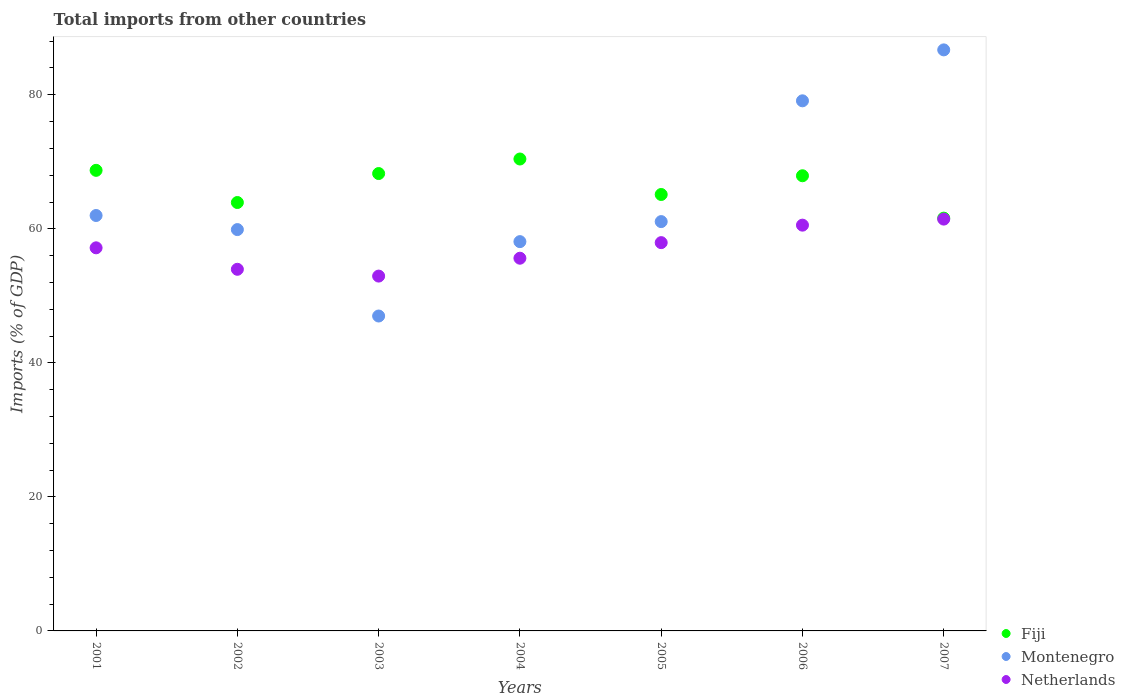Is the number of dotlines equal to the number of legend labels?
Make the answer very short. Yes. What is the total imports in Fiji in 2002?
Offer a very short reply. 63.92. Across all years, what is the maximum total imports in Fiji?
Your answer should be very brief. 70.42. Across all years, what is the minimum total imports in Fiji?
Offer a terse response. 61.59. What is the total total imports in Fiji in the graph?
Provide a short and direct response. 465.94. What is the difference between the total imports in Netherlands in 2002 and that in 2003?
Provide a succinct answer. 1.01. What is the difference between the total imports in Fiji in 2003 and the total imports in Montenegro in 2005?
Make the answer very short. 7.17. What is the average total imports in Netherlands per year?
Your answer should be very brief. 57.09. In the year 2004, what is the difference between the total imports in Netherlands and total imports in Fiji?
Make the answer very short. -14.8. What is the ratio of the total imports in Montenegro in 2001 to that in 2004?
Ensure brevity in your answer.  1.07. Is the total imports in Netherlands in 2001 less than that in 2004?
Ensure brevity in your answer.  No. What is the difference between the highest and the second highest total imports in Montenegro?
Your response must be concise. 7.6. What is the difference between the highest and the lowest total imports in Netherlands?
Your answer should be very brief. 8.5. Is it the case that in every year, the sum of the total imports in Montenegro and total imports in Fiji  is greater than the total imports in Netherlands?
Provide a short and direct response. Yes. Is the total imports in Netherlands strictly less than the total imports in Fiji over the years?
Provide a succinct answer. Yes. How many legend labels are there?
Provide a succinct answer. 3. What is the title of the graph?
Your answer should be very brief. Total imports from other countries. Does "Northern Mariana Islands" appear as one of the legend labels in the graph?
Keep it short and to the point. No. What is the label or title of the X-axis?
Your answer should be very brief. Years. What is the label or title of the Y-axis?
Provide a short and direct response. Imports (% of GDP). What is the Imports (% of GDP) in Fiji in 2001?
Your answer should be compact. 68.73. What is the Imports (% of GDP) of Montenegro in 2001?
Your answer should be compact. 61.99. What is the Imports (% of GDP) of Netherlands in 2001?
Keep it short and to the point. 57.16. What is the Imports (% of GDP) in Fiji in 2002?
Provide a short and direct response. 63.92. What is the Imports (% of GDP) in Montenegro in 2002?
Your answer should be very brief. 59.88. What is the Imports (% of GDP) of Netherlands in 2002?
Your answer should be very brief. 53.96. What is the Imports (% of GDP) in Fiji in 2003?
Provide a succinct answer. 68.25. What is the Imports (% of GDP) of Montenegro in 2003?
Your answer should be compact. 46.99. What is the Imports (% of GDP) in Netherlands in 2003?
Offer a very short reply. 52.95. What is the Imports (% of GDP) in Fiji in 2004?
Your answer should be compact. 70.42. What is the Imports (% of GDP) in Montenegro in 2004?
Give a very brief answer. 58.09. What is the Imports (% of GDP) of Netherlands in 2004?
Keep it short and to the point. 55.61. What is the Imports (% of GDP) in Fiji in 2005?
Provide a short and direct response. 65.12. What is the Imports (% of GDP) of Montenegro in 2005?
Keep it short and to the point. 61.08. What is the Imports (% of GDP) in Netherlands in 2005?
Give a very brief answer. 57.94. What is the Imports (% of GDP) in Fiji in 2006?
Your answer should be very brief. 67.92. What is the Imports (% of GDP) of Montenegro in 2006?
Give a very brief answer. 79.1. What is the Imports (% of GDP) in Netherlands in 2006?
Provide a succinct answer. 60.55. What is the Imports (% of GDP) in Fiji in 2007?
Your answer should be very brief. 61.59. What is the Imports (% of GDP) of Montenegro in 2007?
Make the answer very short. 86.7. What is the Imports (% of GDP) in Netherlands in 2007?
Provide a short and direct response. 61.45. Across all years, what is the maximum Imports (% of GDP) of Fiji?
Provide a short and direct response. 70.42. Across all years, what is the maximum Imports (% of GDP) in Montenegro?
Offer a terse response. 86.7. Across all years, what is the maximum Imports (% of GDP) of Netherlands?
Provide a short and direct response. 61.45. Across all years, what is the minimum Imports (% of GDP) in Fiji?
Ensure brevity in your answer.  61.59. Across all years, what is the minimum Imports (% of GDP) in Montenegro?
Offer a terse response. 46.99. Across all years, what is the minimum Imports (% of GDP) of Netherlands?
Make the answer very short. 52.95. What is the total Imports (% of GDP) in Fiji in the graph?
Ensure brevity in your answer.  465.94. What is the total Imports (% of GDP) in Montenegro in the graph?
Provide a succinct answer. 453.82. What is the total Imports (% of GDP) in Netherlands in the graph?
Your response must be concise. 399.61. What is the difference between the Imports (% of GDP) of Fiji in 2001 and that in 2002?
Provide a short and direct response. 4.8. What is the difference between the Imports (% of GDP) of Montenegro in 2001 and that in 2002?
Your response must be concise. 2.1. What is the difference between the Imports (% of GDP) in Netherlands in 2001 and that in 2002?
Offer a terse response. 3.2. What is the difference between the Imports (% of GDP) of Fiji in 2001 and that in 2003?
Your response must be concise. 0.48. What is the difference between the Imports (% of GDP) of Montenegro in 2001 and that in 2003?
Provide a succinct answer. 15. What is the difference between the Imports (% of GDP) of Netherlands in 2001 and that in 2003?
Provide a succinct answer. 4.22. What is the difference between the Imports (% of GDP) of Fiji in 2001 and that in 2004?
Give a very brief answer. -1.69. What is the difference between the Imports (% of GDP) of Montenegro in 2001 and that in 2004?
Give a very brief answer. 3.9. What is the difference between the Imports (% of GDP) of Netherlands in 2001 and that in 2004?
Provide a succinct answer. 1.55. What is the difference between the Imports (% of GDP) of Fiji in 2001 and that in 2005?
Your answer should be compact. 3.6. What is the difference between the Imports (% of GDP) of Montenegro in 2001 and that in 2005?
Your response must be concise. 0.91. What is the difference between the Imports (% of GDP) of Netherlands in 2001 and that in 2005?
Your response must be concise. -0.77. What is the difference between the Imports (% of GDP) in Fiji in 2001 and that in 2006?
Your answer should be very brief. 0.81. What is the difference between the Imports (% of GDP) of Montenegro in 2001 and that in 2006?
Your response must be concise. -17.11. What is the difference between the Imports (% of GDP) of Netherlands in 2001 and that in 2006?
Your answer should be compact. -3.38. What is the difference between the Imports (% of GDP) of Fiji in 2001 and that in 2007?
Offer a very short reply. 7.13. What is the difference between the Imports (% of GDP) in Montenegro in 2001 and that in 2007?
Keep it short and to the point. -24.71. What is the difference between the Imports (% of GDP) in Netherlands in 2001 and that in 2007?
Give a very brief answer. -4.29. What is the difference between the Imports (% of GDP) of Fiji in 2002 and that in 2003?
Provide a short and direct response. -4.32. What is the difference between the Imports (% of GDP) of Montenegro in 2002 and that in 2003?
Give a very brief answer. 12.9. What is the difference between the Imports (% of GDP) of Netherlands in 2002 and that in 2003?
Offer a very short reply. 1.01. What is the difference between the Imports (% of GDP) of Fiji in 2002 and that in 2004?
Offer a very short reply. -6.49. What is the difference between the Imports (% of GDP) in Montenegro in 2002 and that in 2004?
Your answer should be very brief. 1.8. What is the difference between the Imports (% of GDP) in Netherlands in 2002 and that in 2004?
Make the answer very short. -1.65. What is the difference between the Imports (% of GDP) in Fiji in 2002 and that in 2005?
Your answer should be very brief. -1.2. What is the difference between the Imports (% of GDP) in Montenegro in 2002 and that in 2005?
Offer a terse response. -1.19. What is the difference between the Imports (% of GDP) in Netherlands in 2002 and that in 2005?
Offer a very short reply. -3.98. What is the difference between the Imports (% of GDP) of Fiji in 2002 and that in 2006?
Offer a very short reply. -3.99. What is the difference between the Imports (% of GDP) of Montenegro in 2002 and that in 2006?
Your response must be concise. -19.21. What is the difference between the Imports (% of GDP) of Netherlands in 2002 and that in 2006?
Ensure brevity in your answer.  -6.59. What is the difference between the Imports (% of GDP) of Fiji in 2002 and that in 2007?
Ensure brevity in your answer.  2.33. What is the difference between the Imports (% of GDP) in Montenegro in 2002 and that in 2007?
Provide a short and direct response. -26.81. What is the difference between the Imports (% of GDP) in Netherlands in 2002 and that in 2007?
Give a very brief answer. -7.49. What is the difference between the Imports (% of GDP) in Fiji in 2003 and that in 2004?
Your answer should be very brief. -2.17. What is the difference between the Imports (% of GDP) of Montenegro in 2003 and that in 2004?
Your response must be concise. -11.1. What is the difference between the Imports (% of GDP) of Netherlands in 2003 and that in 2004?
Give a very brief answer. -2.67. What is the difference between the Imports (% of GDP) in Fiji in 2003 and that in 2005?
Your answer should be compact. 3.13. What is the difference between the Imports (% of GDP) of Montenegro in 2003 and that in 2005?
Give a very brief answer. -14.09. What is the difference between the Imports (% of GDP) in Netherlands in 2003 and that in 2005?
Make the answer very short. -4.99. What is the difference between the Imports (% of GDP) in Fiji in 2003 and that in 2006?
Provide a succinct answer. 0.33. What is the difference between the Imports (% of GDP) of Montenegro in 2003 and that in 2006?
Your answer should be very brief. -32.11. What is the difference between the Imports (% of GDP) in Netherlands in 2003 and that in 2006?
Make the answer very short. -7.6. What is the difference between the Imports (% of GDP) of Fiji in 2003 and that in 2007?
Give a very brief answer. 6.65. What is the difference between the Imports (% of GDP) of Montenegro in 2003 and that in 2007?
Offer a terse response. -39.71. What is the difference between the Imports (% of GDP) of Netherlands in 2003 and that in 2007?
Your response must be concise. -8.5. What is the difference between the Imports (% of GDP) in Fiji in 2004 and that in 2005?
Keep it short and to the point. 5.3. What is the difference between the Imports (% of GDP) of Montenegro in 2004 and that in 2005?
Your response must be concise. -2.99. What is the difference between the Imports (% of GDP) in Netherlands in 2004 and that in 2005?
Offer a terse response. -2.32. What is the difference between the Imports (% of GDP) of Fiji in 2004 and that in 2006?
Provide a succinct answer. 2.5. What is the difference between the Imports (% of GDP) in Montenegro in 2004 and that in 2006?
Provide a short and direct response. -21.01. What is the difference between the Imports (% of GDP) of Netherlands in 2004 and that in 2006?
Offer a very short reply. -4.93. What is the difference between the Imports (% of GDP) of Fiji in 2004 and that in 2007?
Keep it short and to the point. 8.82. What is the difference between the Imports (% of GDP) in Montenegro in 2004 and that in 2007?
Ensure brevity in your answer.  -28.61. What is the difference between the Imports (% of GDP) in Netherlands in 2004 and that in 2007?
Give a very brief answer. -5.84. What is the difference between the Imports (% of GDP) of Fiji in 2005 and that in 2006?
Provide a short and direct response. -2.8. What is the difference between the Imports (% of GDP) in Montenegro in 2005 and that in 2006?
Give a very brief answer. -18.02. What is the difference between the Imports (% of GDP) of Netherlands in 2005 and that in 2006?
Your answer should be very brief. -2.61. What is the difference between the Imports (% of GDP) in Fiji in 2005 and that in 2007?
Give a very brief answer. 3.53. What is the difference between the Imports (% of GDP) in Montenegro in 2005 and that in 2007?
Your answer should be compact. -25.62. What is the difference between the Imports (% of GDP) in Netherlands in 2005 and that in 2007?
Ensure brevity in your answer.  -3.51. What is the difference between the Imports (% of GDP) in Fiji in 2006 and that in 2007?
Ensure brevity in your answer.  6.32. What is the difference between the Imports (% of GDP) in Montenegro in 2006 and that in 2007?
Provide a succinct answer. -7.6. What is the difference between the Imports (% of GDP) of Netherlands in 2006 and that in 2007?
Keep it short and to the point. -0.9. What is the difference between the Imports (% of GDP) in Fiji in 2001 and the Imports (% of GDP) in Montenegro in 2002?
Your answer should be very brief. 8.84. What is the difference between the Imports (% of GDP) of Fiji in 2001 and the Imports (% of GDP) of Netherlands in 2002?
Ensure brevity in your answer.  14.77. What is the difference between the Imports (% of GDP) of Montenegro in 2001 and the Imports (% of GDP) of Netherlands in 2002?
Give a very brief answer. 8.03. What is the difference between the Imports (% of GDP) of Fiji in 2001 and the Imports (% of GDP) of Montenegro in 2003?
Keep it short and to the point. 21.74. What is the difference between the Imports (% of GDP) of Fiji in 2001 and the Imports (% of GDP) of Netherlands in 2003?
Your answer should be very brief. 15.78. What is the difference between the Imports (% of GDP) of Montenegro in 2001 and the Imports (% of GDP) of Netherlands in 2003?
Give a very brief answer. 9.04. What is the difference between the Imports (% of GDP) of Fiji in 2001 and the Imports (% of GDP) of Montenegro in 2004?
Your answer should be very brief. 10.64. What is the difference between the Imports (% of GDP) of Fiji in 2001 and the Imports (% of GDP) of Netherlands in 2004?
Your answer should be very brief. 13.11. What is the difference between the Imports (% of GDP) in Montenegro in 2001 and the Imports (% of GDP) in Netherlands in 2004?
Keep it short and to the point. 6.37. What is the difference between the Imports (% of GDP) of Fiji in 2001 and the Imports (% of GDP) of Montenegro in 2005?
Give a very brief answer. 7.65. What is the difference between the Imports (% of GDP) in Fiji in 2001 and the Imports (% of GDP) in Netherlands in 2005?
Provide a short and direct response. 10.79. What is the difference between the Imports (% of GDP) in Montenegro in 2001 and the Imports (% of GDP) in Netherlands in 2005?
Your answer should be very brief. 4.05. What is the difference between the Imports (% of GDP) of Fiji in 2001 and the Imports (% of GDP) of Montenegro in 2006?
Provide a short and direct response. -10.37. What is the difference between the Imports (% of GDP) of Fiji in 2001 and the Imports (% of GDP) of Netherlands in 2006?
Give a very brief answer. 8.18. What is the difference between the Imports (% of GDP) of Montenegro in 2001 and the Imports (% of GDP) of Netherlands in 2006?
Ensure brevity in your answer.  1.44. What is the difference between the Imports (% of GDP) in Fiji in 2001 and the Imports (% of GDP) in Montenegro in 2007?
Give a very brief answer. -17.97. What is the difference between the Imports (% of GDP) of Fiji in 2001 and the Imports (% of GDP) of Netherlands in 2007?
Your response must be concise. 7.28. What is the difference between the Imports (% of GDP) of Montenegro in 2001 and the Imports (% of GDP) of Netherlands in 2007?
Provide a succinct answer. 0.54. What is the difference between the Imports (% of GDP) in Fiji in 2002 and the Imports (% of GDP) in Montenegro in 2003?
Ensure brevity in your answer.  16.94. What is the difference between the Imports (% of GDP) in Fiji in 2002 and the Imports (% of GDP) in Netherlands in 2003?
Ensure brevity in your answer.  10.98. What is the difference between the Imports (% of GDP) of Montenegro in 2002 and the Imports (% of GDP) of Netherlands in 2003?
Provide a succinct answer. 6.94. What is the difference between the Imports (% of GDP) in Fiji in 2002 and the Imports (% of GDP) in Montenegro in 2004?
Provide a succinct answer. 5.84. What is the difference between the Imports (% of GDP) of Fiji in 2002 and the Imports (% of GDP) of Netherlands in 2004?
Provide a succinct answer. 8.31. What is the difference between the Imports (% of GDP) of Montenegro in 2002 and the Imports (% of GDP) of Netherlands in 2004?
Your response must be concise. 4.27. What is the difference between the Imports (% of GDP) of Fiji in 2002 and the Imports (% of GDP) of Montenegro in 2005?
Ensure brevity in your answer.  2.85. What is the difference between the Imports (% of GDP) in Fiji in 2002 and the Imports (% of GDP) in Netherlands in 2005?
Give a very brief answer. 5.99. What is the difference between the Imports (% of GDP) of Montenegro in 2002 and the Imports (% of GDP) of Netherlands in 2005?
Your answer should be very brief. 1.95. What is the difference between the Imports (% of GDP) of Fiji in 2002 and the Imports (% of GDP) of Montenegro in 2006?
Make the answer very short. -15.17. What is the difference between the Imports (% of GDP) of Fiji in 2002 and the Imports (% of GDP) of Netherlands in 2006?
Offer a terse response. 3.38. What is the difference between the Imports (% of GDP) in Montenegro in 2002 and the Imports (% of GDP) in Netherlands in 2006?
Keep it short and to the point. -0.66. What is the difference between the Imports (% of GDP) in Fiji in 2002 and the Imports (% of GDP) in Montenegro in 2007?
Offer a terse response. -22.77. What is the difference between the Imports (% of GDP) of Fiji in 2002 and the Imports (% of GDP) of Netherlands in 2007?
Your answer should be very brief. 2.48. What is the difference between the Imports (% of GDP) in Montenegro in 2002 and the Imports (% of GDP) in Netherlands in 2007?
Your response must be concise. -1.56. What is the difference between the Imports (% of GDP) of Fiji in 2003 and the Imports (% of GDP) of Montenegro in 2004?
Ensure brevity in your answer.  10.16. What is the difference between the Imports (% of GDP) of Fiji in 2003 and the Imports (% of GDP) of Netherlands in 2004?
Make the answer very short. 12.63. What is the difference between the Imports (% of GDP) in Montenegro in 2003 and the Imports (% of GDP) in Netherlands in 2004?
Offer a very short reply. -8.62. What is the difference between the Imports (% of GDP) of Fiji in 2003 and the Imports (% of GDP) of Montenegro in 2005?
Provide a short and direct response. 7.17. What is the difference between the Imports (% of GDP) of Fiji in 2003 and the Imports (% of GDP) of Netherlands in 2005?
Your answer should be compact. 10.31. What is the difference between the Imports (% of GDP) of Montenegro in 2003 and the Imports (% of GDP) of Netherlands in 2005?
Your answer should be very brief. -10.95. What is the difference between the Imports (% of GDP) of Fiji in 2003 and the Imports (% of GDP) of Montenegro in 2006?
Make the answer very short. -10.85. What is the difference between the Imports (% of GDP) of Fiji in 2003 and the Imports (% of GDP) of Netherlands in 2006?
Offer a terse response. 7.7. What is the difference between the Imports (% of GDP) of Montenegro in 2003 and the Imports (% of GDP) of Netherlands in 2006?
Your answer should be compact. -13.56. What is the difference between the Imports (% of GDP) of Fiji in 2003 and the Imports (% of GDP) of Montenegro in 2007?
Offer a very short reply. -18.45. What is the difference between the Imports (% of GDP) in Fiji in 2003 and the Imports (% of GDP) in Netherlands in 2007?
Your response must be concise. 6.8. What is the difference between the Imports (% of GDP) of Montenegro in 2003 and the Imports (% of GDP) of Netherlands in 2007?
Your response must be concise. -14.46. What is the difference between the Imports (% of GDP) of Fiji in 2004 and the Imports (% of GDP) of Montenegro in 2005?
Make the answer very short. 9.34. What is the difference between the Imports (% of GDP) of Fiji in 2004 and the Imports (% of GDP) of Netherlands in 2005?
Keep it short and to the point. 12.48. What is the difference between the Imports (% of GDP) of Montenegro in 2004 and the Imports (% of GDP) of Netherlands in 2005?
Your response must be concise. 0.15. What is the difference between the Imports (% of GDP) in Fiji in 2004 and the Imports (% of GDP) in Montenegro in 2006?
Your answer should be very brief. -8.68. What is the difference between the Imports (% of GDP) of Fiji in 2004 and the Imports (% of GDP) of Netherlands in 2006?
Give a very brief answer. 9.87. What is the difference between the Imports (% of GDP) of Montenegro in 2004 and the Imports (% of GDP) of Netherlands in 2006?
Your response must be concise. -2.46. What is the difference between the Imports (% of GDP) in Fiji in 2004 and the Imports (% of GDP) in Montenegro in 2007?
Your answer should be compact. -16.28. What is the difference between the Imports (% of GDP) of Fiji in 2004 and the Imports (% of GDP) of Netherlands in 2007?
Your response must be concise. 8.97. What is the difference between the Imports (% of GDP) of Montenegro in 2004 and the Imports (% of GDP) of Netherlands in 2007?
Provide a short and direct response. -3.36. What is the difference between the Imports (% of GDP) of Fiji in 2005 and the Imports (% of GDP) of Montenegro in 2006?
Your answer should be very brief. -13.98. What is the difference between the Imports (% of GDP) of Fiji in 2005 and the Imports (% of GDP) of Netherlands in 2006?
Offer a very short reply. 4.57. What is the difference between the Imports (% of GDP) of Montenegro in 2005 and the Imports (% of GDP) of Netherlands in 2006?
Give a very brief answer. 0.53. What is the difference between the Imports (% of GDP) in Fiji in 2005 and the Imports (% of GDP) in Montenegro in 2007?
Keep it short and to the point. -21.58. What is the difference between the Imports (% of GDP) in Fiji in 2005 and the Imports (% of GDP) in Netherlands in 2007?
Offer a very short reply. 3.67. What is the difference between the Imports (% of GDP) in Montenegro in 2005 and the Imports (% of GDP) in Netherlands in 2007?
Give a very brief answer. -0.37. What is the difference between the Imports (% of GDP) in Fiji in 2006 and the Imports (% of GDP) in Montenegro in 2007?
Your answer should be very brief. -18.78. What is the difference between the Imports (% of GDP) in Fiji in 2006 and the Imports (% of GDP) in Netherlands in 2007?
Offer a terse response. 6.47. What is the difference between the Imports (% of GDP) of Montenegro in 2006 and the Imports (% of GDP) of Netherlands in 2007?
Keep it short and to the point. 17.65. What is the average Imports (% of GDP) of Fiji per year?
Make the answer very short. 66.56. What is the average Imports (% of GDP) of Montenegro per year?
Your response must be concise. 64.83. What is the average Imports (% of GDP) of Netherlands per year?
Make the answer very short. 57.09. In the year 2001, what is the difference between the Imports (% of GDP) of Fiji and Imports (% of GDP) of Montenegro?
Your answer should be compact. 6.74. In the year 2001, what is the difference between the Imports (% of GDP) of Fiji and Imports (% of GDP) of Netherlands?
Your answer should be compact. 11.56. In the year 2001, what is the difference between the Imports (% of GDP) of Montenegro and Imports (% of GDP) of Netherlands?
Provide a succinct answer. 4.82. In the year 2002, what is the difference between the Imports (% of GDP) of Fiji and Imports (% of GDP) of Montenegro?
Keep it short and to the point. 4.04. In the year 2002, what is the difference between the Imports (% of GDP) of Fiji and Imports (% of GDP) of Netherlands?
Keep it short and to the point. 9.96. In the year 2002, what is the difference between the Imports (% of GDP) of Montenegro and Imports (% of GDP) of Netherlands?
Provide a short and direct response. 5.92. In the year 2003, what is the difference between the Imports (% of GDP) of Fiji and Imports (% of GDP) of Montenegro?
Offer a terse response. 21.26. In the year 2003, what is the difference between the Imports (% of GDP) of Fiji and Imports (% of GDP) of Netherlands?
Provide a succinct answer. 15.3. In the year 2003, what is the difference between the Imports (% of GDP) in Montenegro and Imports (% of GDP) in Netherlands?
Provide a short and direct response. -5.96. In the year 2004, what is the difference between the Imports (% of GDP) in Fiji and Imports (% of GDP) in Montenegro?
Your answer should be very brief. 12.33. In the year 2004, what is the difference between the Imports (% of GDP) of Fiji and Imports (% of GDP) of Netherlands?
Offer a terse response. 14.8. In the year 2004, what is the difference between the Imports (% of GDP) of Montenegro and Imports (% of GDP) of Netherlands?
Provide a succinct answer. 2.47. In the year 2005, what is the difference between the Imports (% of GDP) of Fiji and Imports (% of GDP) of Montenegro?
Provide a short and direct response. 4.04. In the year 2005, what is the difference between the Imports (% of GDP) in Fiji and Imports (% of GDP) in Netherlands?
Your answer should be compact. 7.18. In the year 2005, what is the difference between the Imports (% of GDP) in Montenegro and Imports (% of GDP) in Netherlands?
Your answer should be very brief. 3.14. In the year 2006, what is the difference between the Imports (% of GDP) in Fiji and Imports (% of GDP) in Montenegro?
Provide a succinct answer. -11.18. In the year 2006, what is the difference between the Imports (% of GDP) in Fiji and Imports (% of GDP) in Netherlands?
Offer a terse response. 7.37. In the year 2006, what is the difference between the Imports (% of GDP) in Montenegro and Imports (% of GDP) in Netherlands?
Give a very brief answer. 18.55. In the year 2007, what is the difference between the Imports (% of GDP) in Fiji and Imports (% of GDP) in Montenegro?
Provide a short and direct response. -25.1. In the year 2007, what is the difference between the Imports (% of GDP) in Fiji and Imports (% of GDP) in Netherlands?
Ensure brevity in your answer.  0.15. In the year 2007, what is the difference between the Imports (% of GDP) of Montenegro and Imports (% of GDP) of Netherlands?
Ensure brevity in your answer.  25.25. What is the ratio of the Imports (% of GDP) in Fiji in 2001 to that in 2002?
Make the answer very short. 1.08. What is the ratio of the Imports (% of GDP) of Montenegro in 2001 to that in 2002?
Provide a short and direct response. 1.04. What is the ratio of the Imports (% of GDP) of Netherlands in 2001 to that in 2002?
Keep it short and to the point. 1.06. What is the ratio of the Imports (% of GDP) in Fiji in 2001 to that in 2003?
Your response must be concise. 1.01. What is the ratio of the Imports (% of GDP) in Montenegro in 2001 to that in 2003?
Your answer should be very brief. 1.32. What is the ratio of the Imports (% of GDP) of Netherlands in 2001 to that in 2003?
Offer a terse response. 1.08. What is the ratio of the Imports (% of GDP) in Fiji in 2001 to that in 2004?
Your response must be concise. 0.98. What is the ratio of the Imports (% of GDP) in Montenegro in 2001 to that in 2004?
Offer a very short reply. 1.07. What is the ratio of the Imports (% of GDP) in Netherlands in 2001 to that in 2004?
Your response must be concise. 1.03. What is the ratio of the Imports (% of GDP) of Fiji in 2001 to that in 2005?
Provide a short and direct response. 1.06. What is the ratio of the Imports (% of GDP) in Montenegro in 2001 to that in 2005?
Offer a terse response. 1.01. What is the ratio of the Imports (% of GDP) of Netherlands in 2001 to that in 2005?
Provide a short and direct response. 0.99. What is the ratio of the Imports (% of GDP) in Fiji in 2001 to that in 2006?
Give a very brief answer. 1.01. What is the ratio of the Imports (% of GDP) of Montenegro in 2001 to that in 2006?
Provide a succinct answer. 0.78. What is the ratio of the Imports (% of GDP) of Netherlands in 2001 to that in 2006?
Give a very brief answer. 0.94. What is the ratio of the Imports (% of GDP) in Fiji in 2001 to that in 2007?
Give a very brief answer. 1.12. What is the ratio of the Imports (% of GDP) in Montenegro in 2001 to that in 2007?
Make the answer very short. 0.71. What is the ratio of the Imports (% of GDP) of Netherlands in 2001 to that in 2007?
Offer a very short reply. 0.93. What is the ratio of the Imports (% of GDP) in Fiji in 2002 to that in 2003?
Your response must be concise. 0.94. What is the ratio of the Imports (% of GDP) in Montenegro in 2002 to that in 2003?
Offer a very short reply. 1.27. What is the ratio of the Imports (% of GDP) of Netherlands in 2002 to that in 2003?
Your response must be concise. 1.02. What is the ratio of the Imports (% of GDP) in Fiji in 2002 to that in 2004?
Offer a terse response. 0.91. What is the ratio of the Imports (% of GDP) in Montenegro in 2002 to that in 2004?
Your response must be concise. 1.03. What is the ratio of the Imports (% of GDP) of Netherlands in 2002 to that in 2004?
Make the answer very short. 0.97. What is the ratio of the Imports (% of GDP) of Fiji in 2002 to that in 2005?
Offer a terse response. 0.98. What is the ratio of the Imports (% of GDP) of Montenegro in 2002 to that in 2005?
Provide a short and direct response. 0.98. What is the ratio of the Imports (% of GDP) of Netherlands in 2002 to that in 2005?
Your answer should be compact. 0.93. What is the ratio of the Imports (% of GDP) in Montenegro in 2002 to that in 2006?
Make the answer very short. 0.76. What is the ratio of the Imports (% of GDP) of Netherlands in 2002 to that in 2006?
Ensure brevity in your answer.  0.89. What is the ratio of the Imports (% of GDP) of Fiji in 2002 to that in 2007?
Give a very brief answer. 1.04. What is the ratio of the Imports (% of GDP) of Montenegro in 2002 to that in 2007?
Your answer should be compact. 0.69. What is the ratio of the Imports (% of GDP) in Netherlands in 2002 to that in 2007?
Your answer should be very brief. 0.88. What is the ratio of the Imports (% of GDP) in Fiji in 2003 to that in 2004?
Keep it short and to the point. 0.97. What is the ratio of the Imports (% of GDP) of Montenegro in 2003 to that in 2004?
Make the answer very short. 0.81. What is the ratio of the Imports (% of GDP) in Netherlands in 2003 to that in 2004?
Your answer should be very brief. 0.95. What is the ratio of the Imports (% of GDP) of Fiji in 2003 to that in 2005?
Make the answer very short. 1.05. What is the ratio of the Imports (% of GDP) in Montenegro in 2003 to that in 2005?
Provide a succinct answer. 0.77. What is the ratio of the Imports (% of GDP) of Netherlands in 2003 to that in 2005?
Give a very brief answer. 0.91. What is the ratio of the Imports (% of GDP) of Montenegro in 2003 to that in 2006?
Provide a succinct answer. 0.59. What is the ratio of the Imports (% of GDP) in Netherlands in 2003 to that in 2006?
Your answer should be very brief. 0.87. What is the ratio of the Imports (% of GDP) in Fiji in 2003 to that in 2007?
Provide a short and direct response. 1.11. What is the ratio of the Imports (% of GDP) of Montenegro in 2003 to that in 2007?
Give a very brief answer. 0.54. What is the ratio of the Imports (% of GDP) of Netherlands in 2003 to that in 2007?
Make the answer very short. 0.86. What is the ratio of the Imports (% of GDP) in Fiji in 2004 to that in 2005?
Offer a very short reply. 1.08. What is the ratio of the Imports (% of GDP) in Montenegro in 2004 to that in 2005?
Provide a short and direct response. 0.95. What is the ratio of the Imports (% of GDP) in Netherlands in 2004 to that in 2005?
Keep it short and to the point. 0.96. What is the ratio of the Imports (% of GDP) of Fiji in 2004 to that in 2006?
Ensure brevity in your answer.  1.04. What is the ratio of the Imports (% of GDP) of Montenegro in 2004 to that in 2006?
Provide a succinct answer. 0.73. What is the ratio of the Imports (% of GDP) of Netherlands in 2004 to that in 2006?
Make the answer very short. 0.92. What is the ratio of the Imports (% of GDP) in Fiji in 2004 to that in 2007?
Ensure brevity in your answer.  1.14. What is the ratio of the Imports (% of GDP) of Montenegro in 2004 to that in 2007?
Offer a very short reply. 0.67. What is the ratio of the Imports (% of GDP) in Netherlands in 2004 to that in 2007?
Provide a short and direct response. 0.91. What is the ratio of the Imports (% of GDP) of Fiji in 2005 to that in 2006?
Provide a short and direct response. 0.96. What is the ratio of the Imports (% of GDP) of Montenegro in 2005 to that in 2006?
Provide a short and direct response. 0.77. What is the ratio of the Imports (% of GDP) of Netherlands in 2005 to that in 2006?
Offer a very short reply. 0.96. What is the ratio of the Imports (% of GDP) in Fiji in 2005 to that in 2007?
Keep it short and to the point. 1.06. What is the ratio of the Imports (% of GDP) in Montenegro in 2005 to that in 2007?
Offer a terse response. 0.7. What is the ratio of the Imports (% of GDP) in Netherlands in 2005 to that in 2007?
Give a very brief answer. 0.94. What is the ratio of the Imports (% of GDP) in Fiji in 2006 to that in 2007?
Give a very brief answer. 1.1. What is the ratio of the Imports (% of GDP) of Montenegro in 2006 to that in 2007?
Your answer should be compact. 0.91. What is the ratio of the Imports (% of GDP) of Netherlands in 2006 to that in 2007?
Your response must be concise. 0.99. What is the difference between the highest and the second highest Imports (% of GDP) of Fiji?
Your answer should be very brief. 1.69. What is the difference between the highest and the second highest Imports (% of GDP) in Montenegro?
Keep it short and to the point. 7.6. What is the difference between the highest and the second highest Imports (% of GDP) in Netherlands?
Your answer should be compact. 0.9. What is the difference between the highest and the lowest Imports (% of GDP) of Fiji?
Make the answer very short. 8.82. What is the difference between the highest and the lowest Imports (% of GDP) in Montenegro?
Offer a terse response. 39.71. What is the difference between the highest and the lowest Imports (% of GDP) in Netherlands?
Offer a terse response. 8.5. 